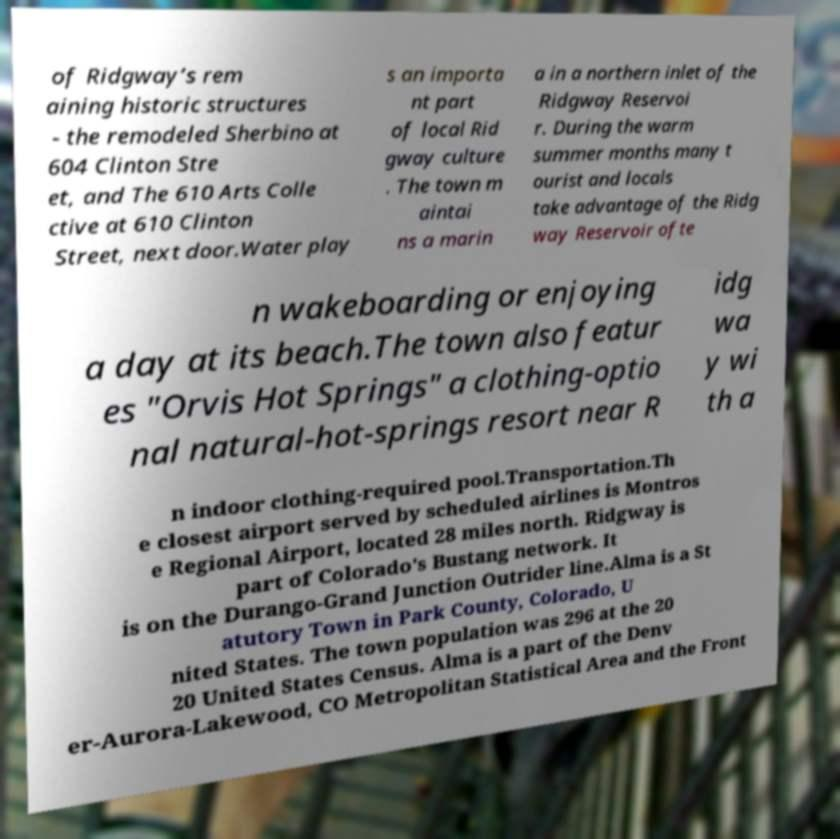Can you accurately transcribe the text from the provided image for me? of Ridgway’s rem aining historic structures - the remodeled Sherbino at 604 Clinton Stre et, and The 610 Arts Colle ctive at 610 Clinton Street, next door.Water play s an importa nt part of local Rid gway culture . The town m aintai ns a marin a in a northern inlet of the Ridgway Reservoi r. During the warm summer months many t ourist and locals take advantage of the Ridg way Reservoir ofte n wakeboarding or enjoying a day at its beach.The town also featur es "Orvis Hot Springs" a clothing-optio nal natural-hot-springs resort near R idg wa y wi th a n indoor clothing-required pool.Transportation.Th e closest airport served by scheduled airlines is Montros e Regional Airport, located 28 miles north. Ridgway is part of Colorado's Bustang network. It is on the Durango-Grand Junction Outrider line.Alma is a St atutory Town in Park County, Colorado, U nited States. The town population was 296 at the 20 20 United States Census. Alma is a part of the Denv er-Aurora-Lakewood, CO Metropolitan Statistical Area and the Front 